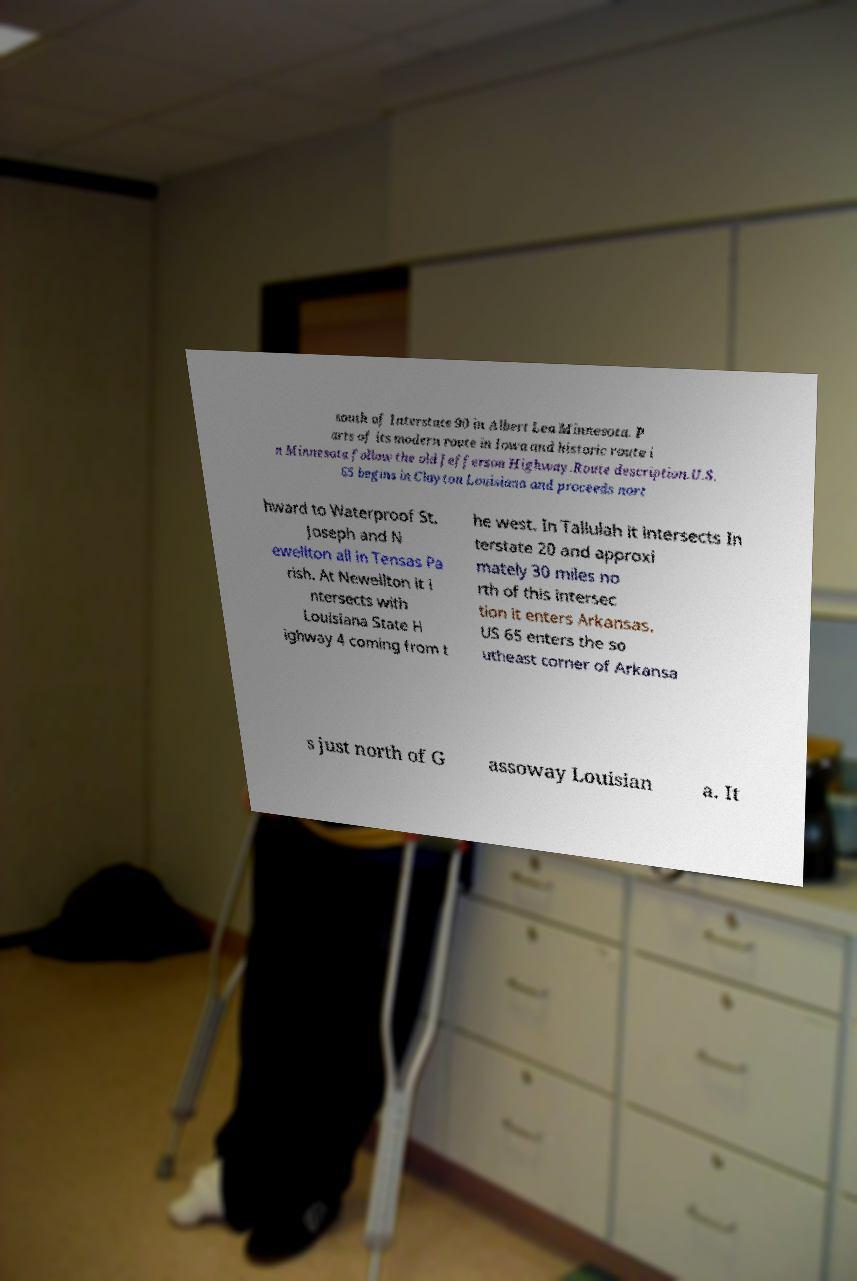Please identify and transcribe the text found in this image. south of Interstate 90 in Albert Lea Minnesota. P arts of its modern route in Iowa and historic route i n Minnesota follow the old Jefferson Highway.Route description.U.S. 65 begins in Clayton Louisiana and proceeds nort hward to Waterproof St. Joseph and N ewellton all in Tensas Pa rish. At Newellton it i ntersects with Louisiana State H ighway 4 coming from t he west. In Tallulah it intersects In terstate 20 and approxi mately 30 miles no rth of this intersec tion it enters Arkansas. US 65 enters the so utheast corner of Arkansa s just north of G assoway Louisian a. It 